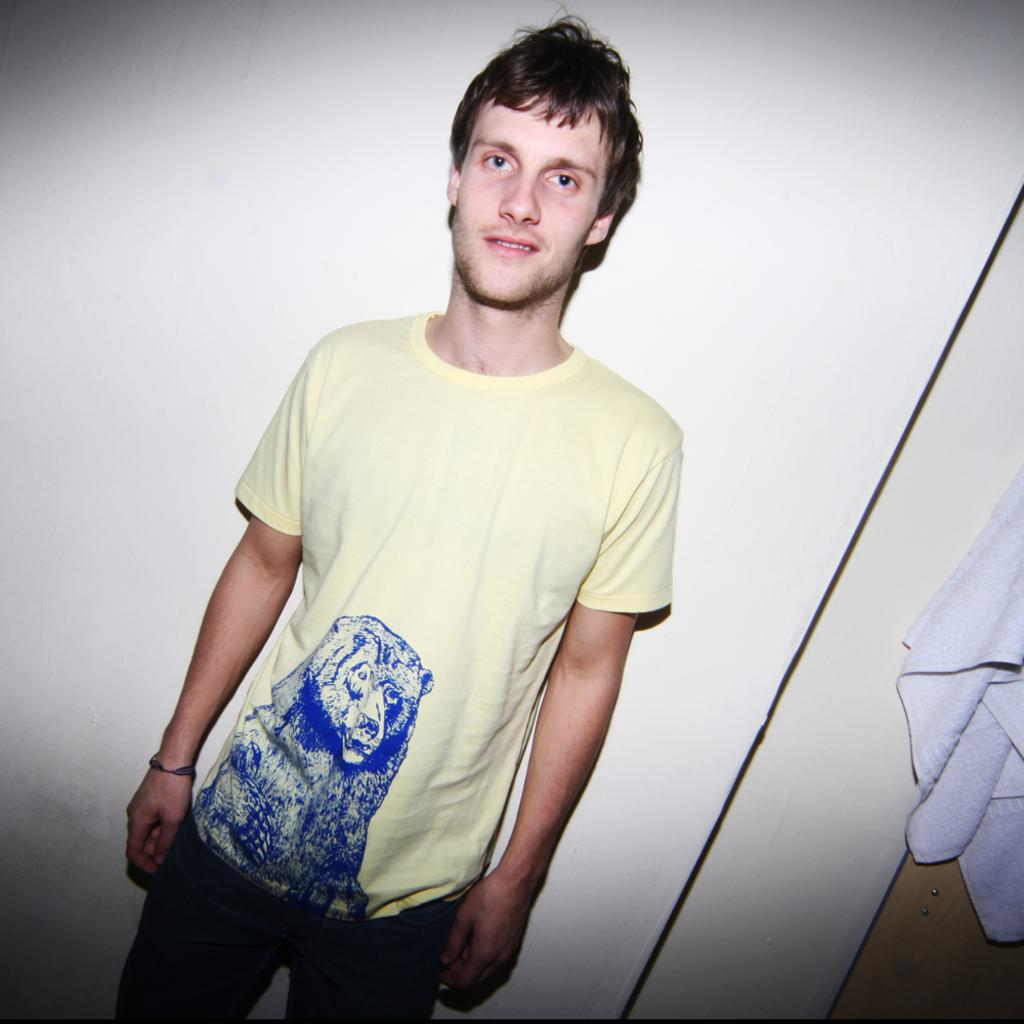What is the main subject of the image? There is a man standing in the center of the image. What object can be seen on the right side of the image? There is a towel on the right side of the image. What is visible in the background of the image? There is a wall in the background of the image. What type of sign can be seen on the desk in the image? There is no desk or sign present in the image. What word is written on the wall in the image? There is no word visible on the wall in the image. 